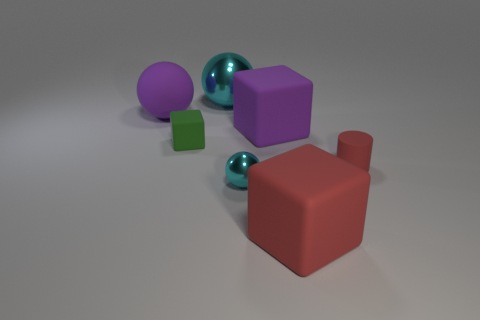Subtract all large matte cubes. How many cubes are left? 1 Add 1 tiny things. How many objects exist? 8 Subtract all cylinders. How many objects are left? 6 Add 7 purple rubber things. How many purple rubber things are left? 9 Add 1 large cyan shiny balls. How many large cyan shiny balls exist? 2 Subtract 0 purple cylinders. How many objects are left? 7 Subtract all purple spheres. Subtract all red cylinders. How many objects are left? 5 